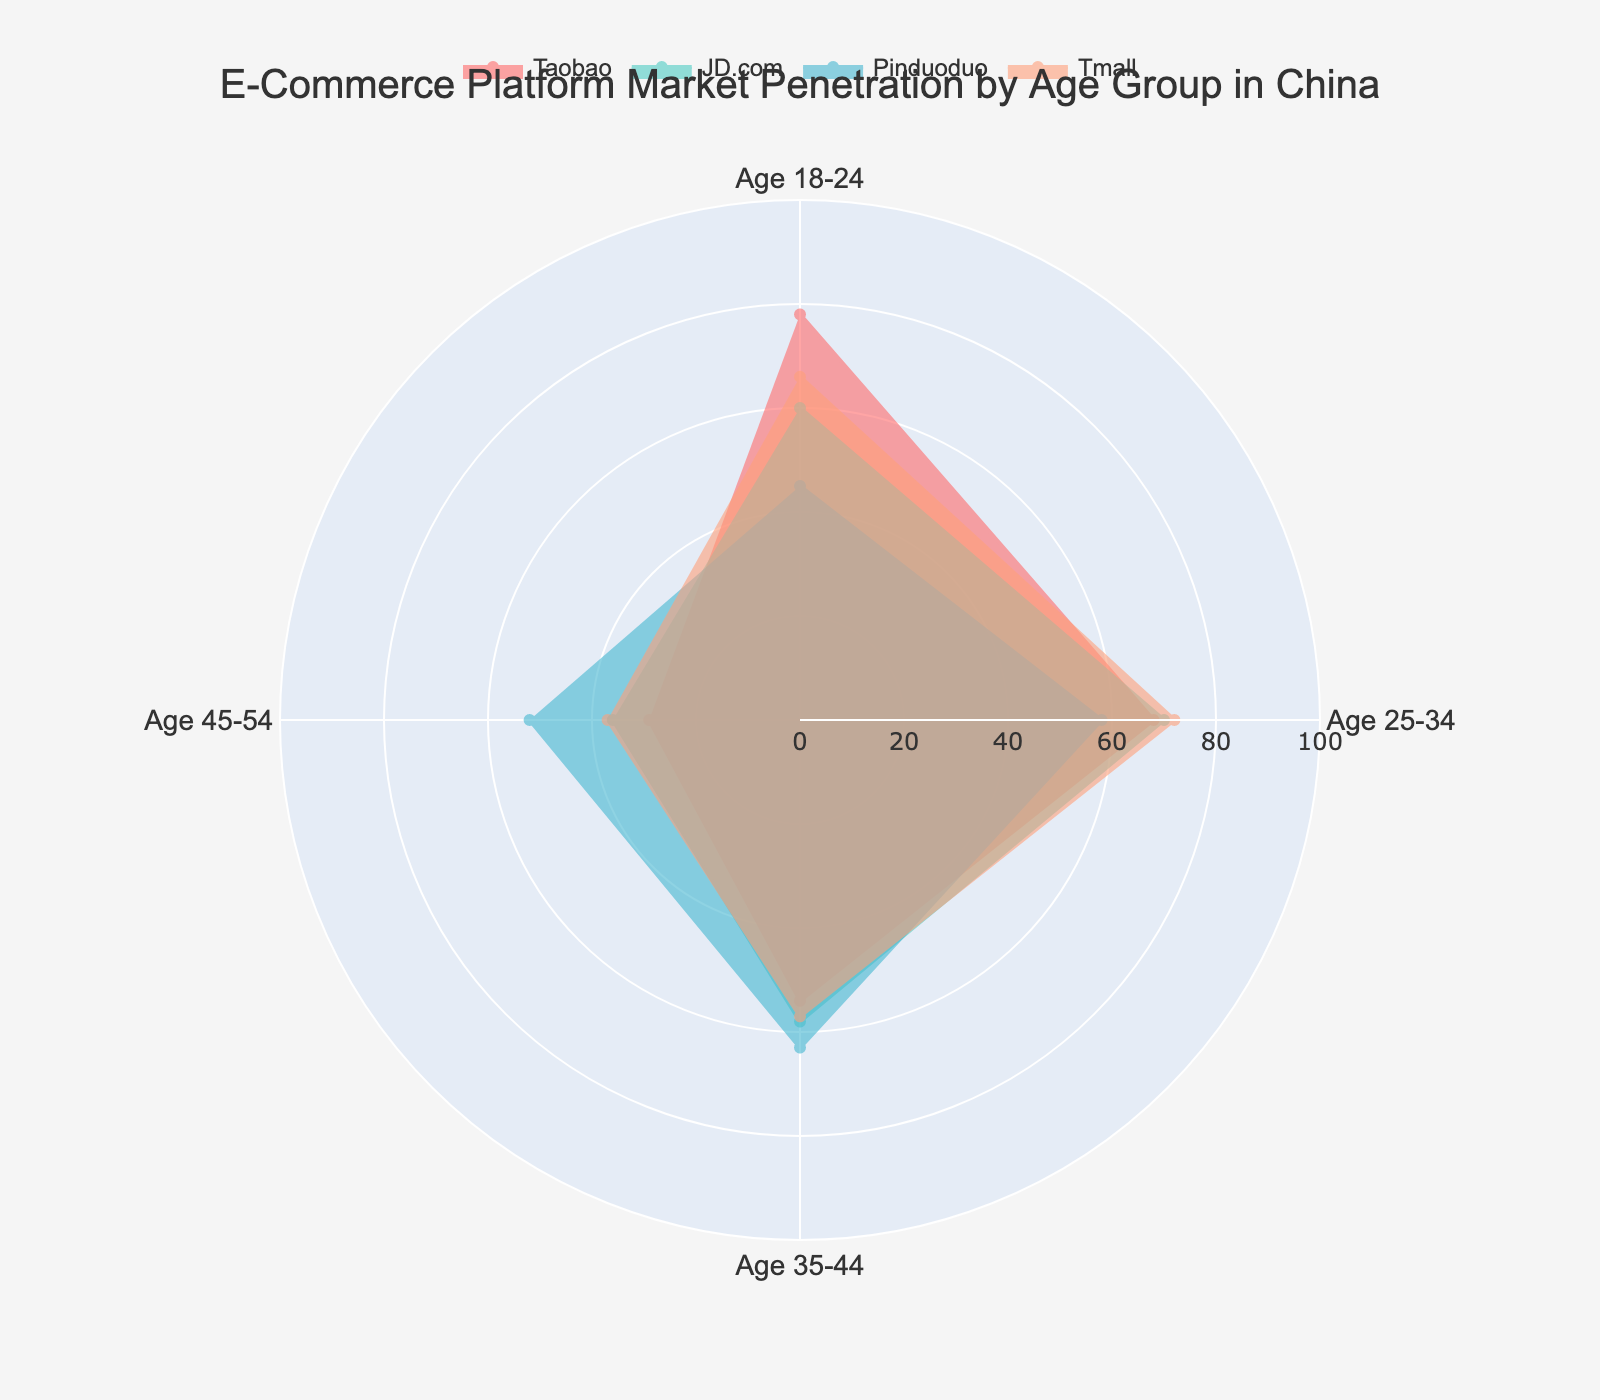What is the highest market penetration for Taobao? By looking at the radar chart for Taobao, we check the values at the edges of the shape, and the highest value is in the Age 18-24 group, which is 78.
Answer: 78 What platform has the lowest market penetration among Age 45-54? We compare the values in the Age 45-54 group for each platform (Taobao: 29, JD.com: 36, Pinduoduo: 52, Tmall: 37) and find the lowest value is for Taobao.
Answer: Taobao Which age group shows the highest market penetration for Tmall? By looking at Tmall's values on the radar chart, we identify that the group Age 25-34 has the highest penetration at 72.
Answer: Age 25-34 Which platform has the most balanced (least varying) penetration across all age groups? We check the range of values for each platform. Taobao ranges from 29 to 78, JD.com from 36 to 70, Pinduoduo from 45 to 63, and Tmall from 37 to 72. JD.com has the narrowest range of values, indicating a more balanced penetration.
Answer: JD.com Rank the platforms for Age 35-44 from highest to lowest market penetration. We compare penetration values for Age 35-44: Taobao (54), JD.com (58), Pinduoduo (63), Tmall (57). The ranking is Pinduoduo, JD.com, Tmall, Taobao.
Answer: Pinduoduo, JD.com, Tmall, Taobao What is the average market penetration for JD.com across all age groups? To find the average, sum the values for JD.com (60+70+58+36=224), then divide by the number of age groups (224/4=56).
Answer: 56 Which platform shows the greatest increase in penetration between Age 25-34 and Age 35-44? We calculate the difference between Age 25-34 and Age 35-44 for each platform: Taobao (68-54=14), JD.com (70-58=12), Pinduoduo (58-63=-5), Tmall (72-57=15). Tmall shows the greatest increase.
Answer: Tmall What is the total market penetration for Pinduoduo for all age groups combined? Sum all values for Pinduoduo (45+58+63+52=218).
Answer: 218 Which age group has the lowest average market penetration across all platforms? To find this, calculate the average for each age group: Age 18-24: (78+60+45+66)/4=62.25, Age 25-34: (68+70+58+72)/4=67, Age 35-44: (54+58+63+57)/4=58, Age 45-54: (29+36+52+37)/4=38.5. Age 45-54 has the lowest average.
Answer: Age 45-54 